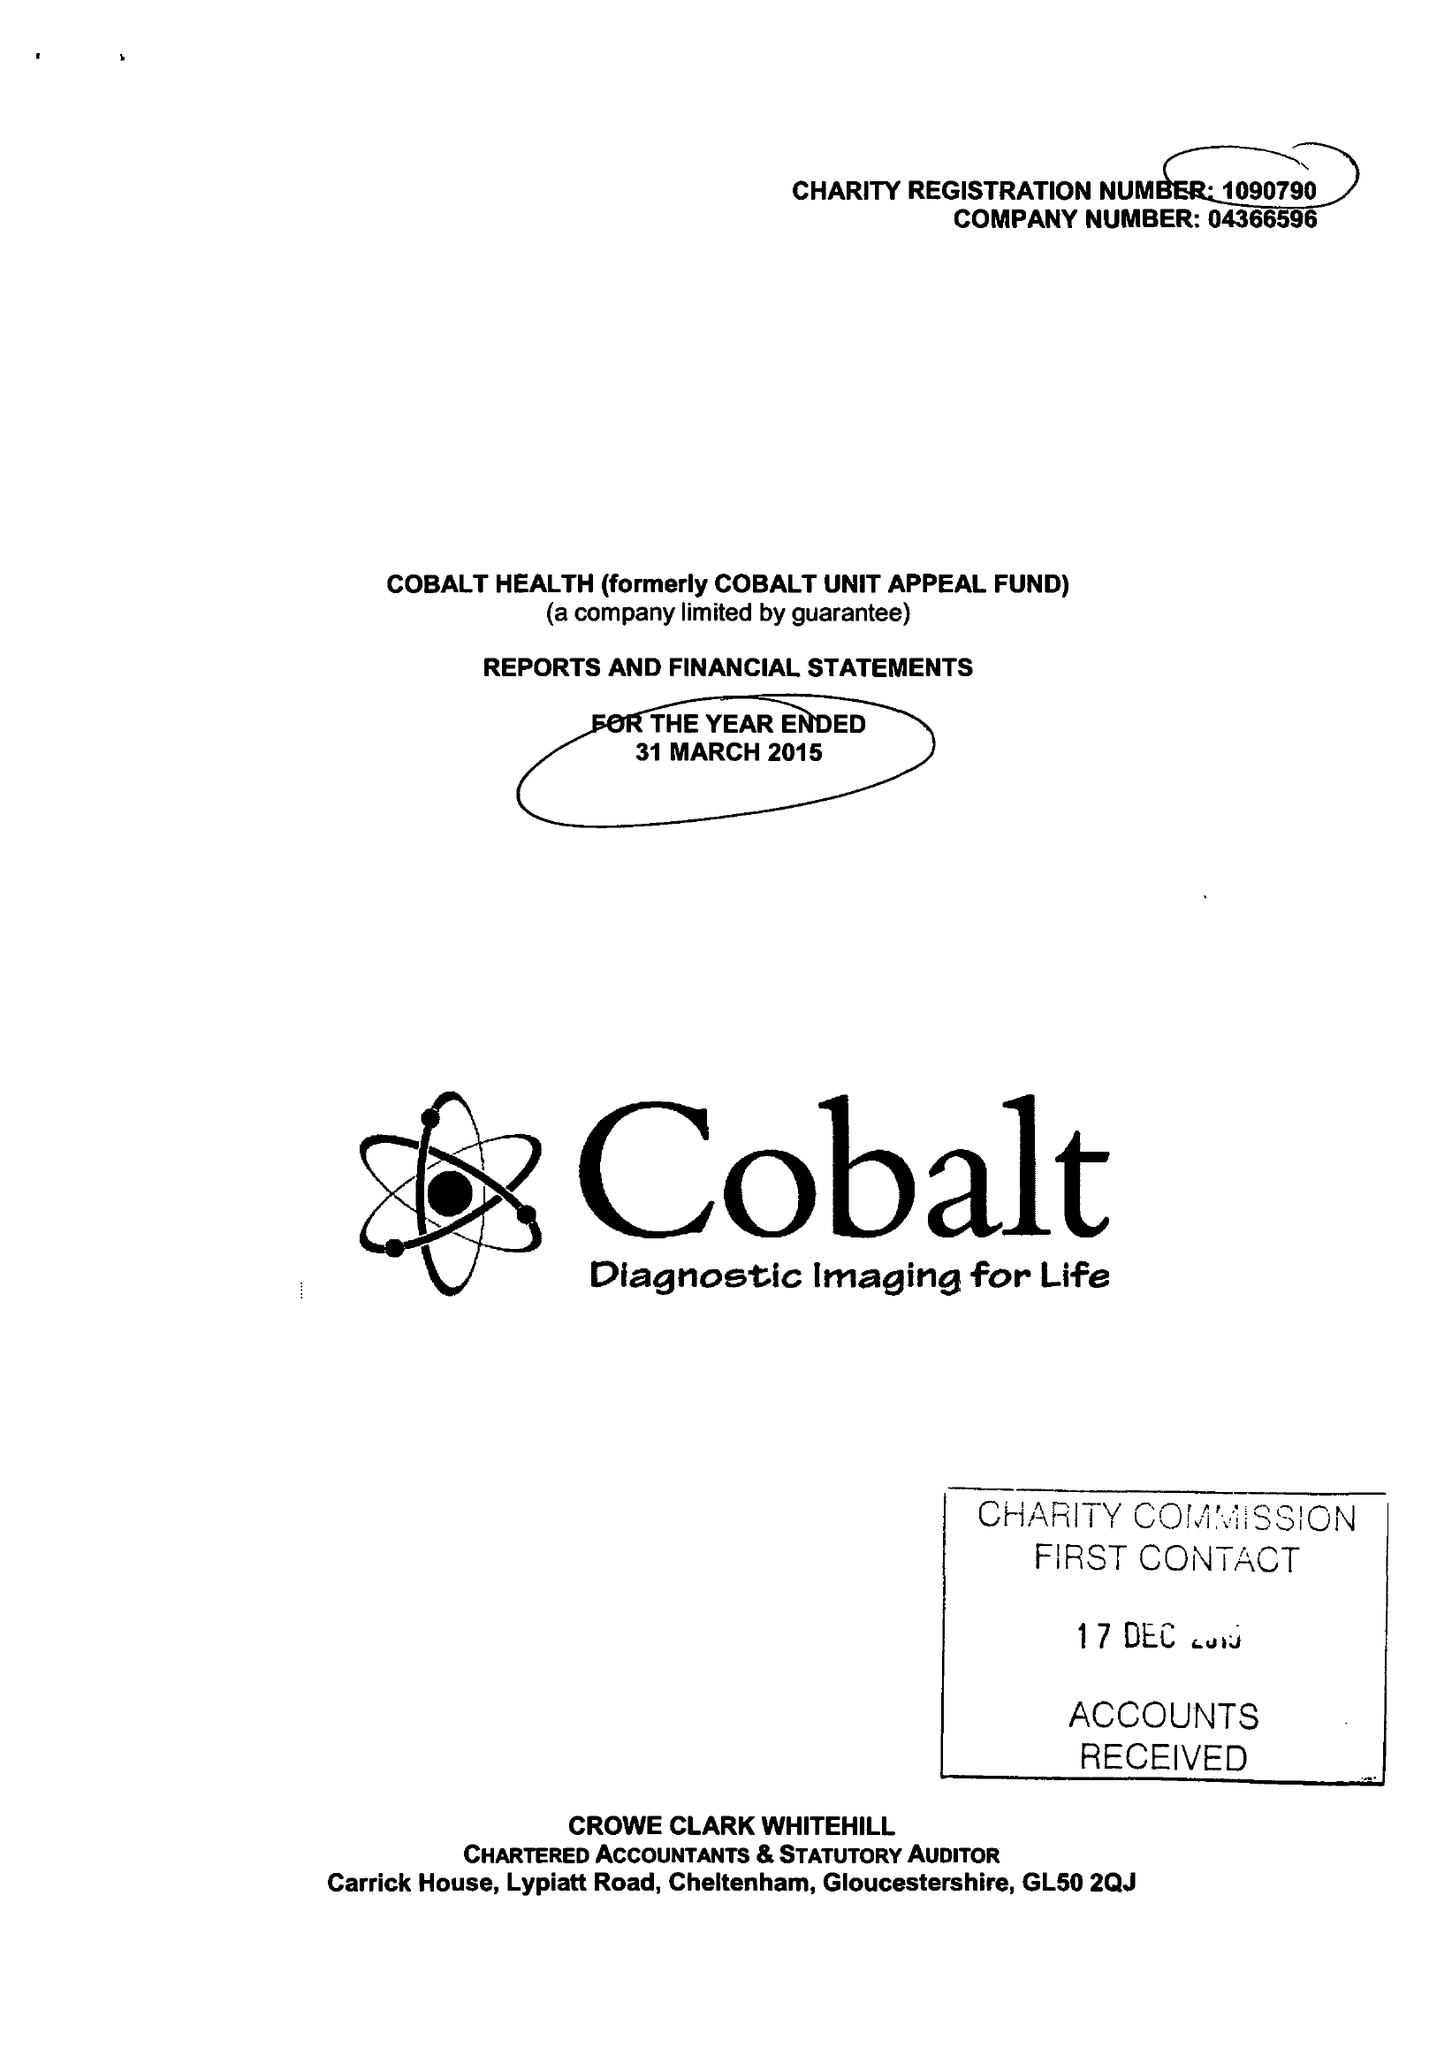What is the value for the income_annually_in_british_pounds?
Answer the question using a single word or phrase. 8200792.00 